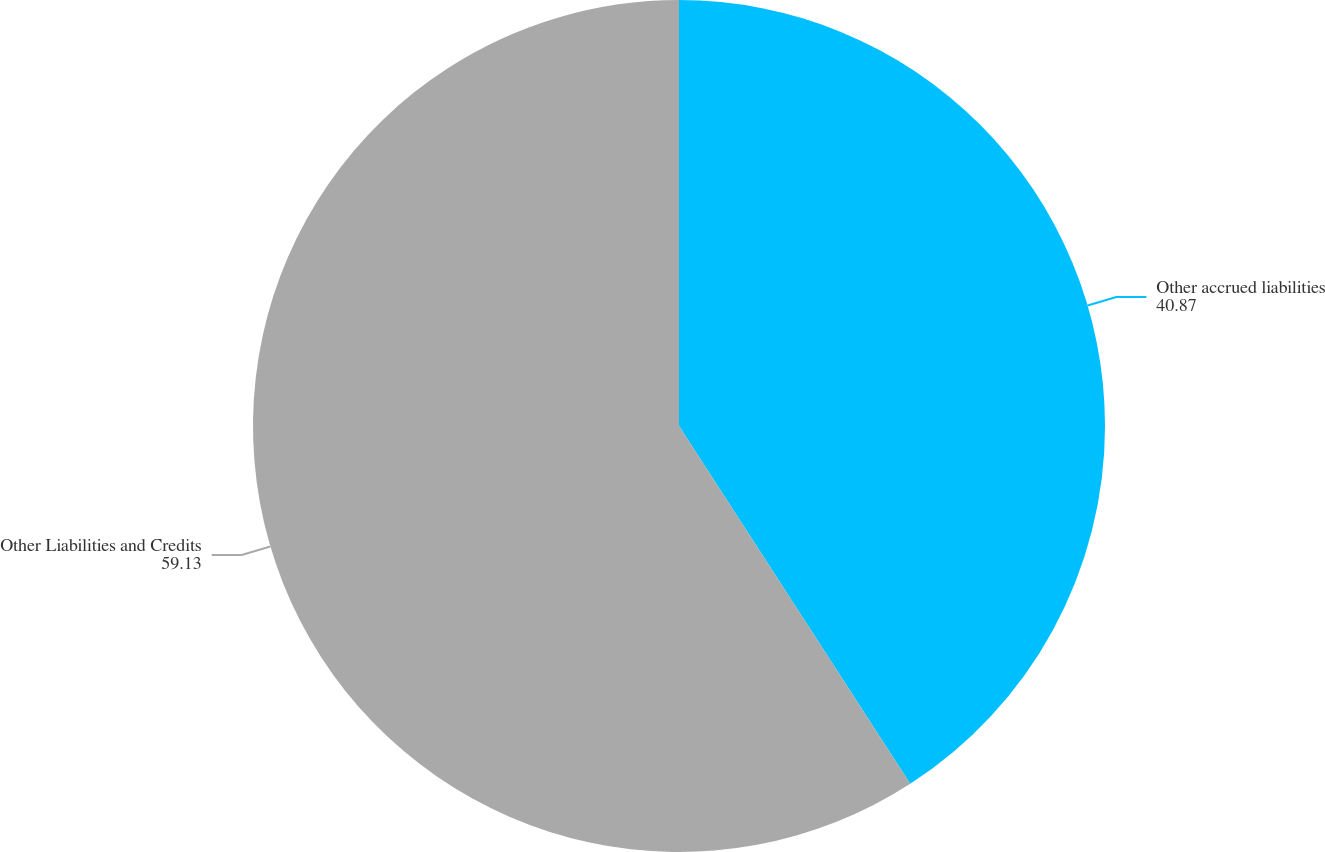Convert chart to OTSL. <chart><loc_0><loc_0><loc_500><loc_500><pie_chart><fcel>Other accrued liabilities<fcel>Other Liabilities and Credits<nl><fcel>40.87%<fcel>59.13%<nl></chart> 